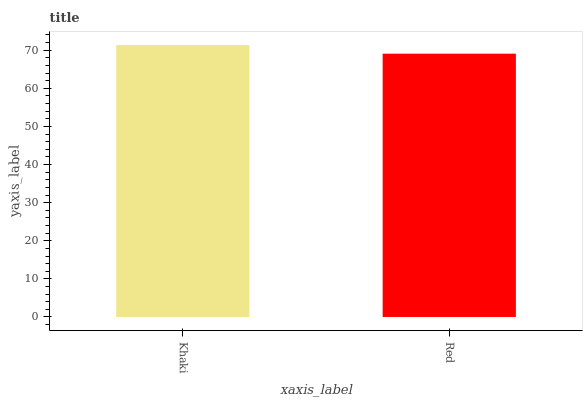Is Red the minimum?
Answer yes or no. Yes. Is Khaki the maximum?
Answer yes or no. Yes. Is Red the maximum?
Answer yes or no. No. Is Khaki greater than Red?
Answer yes or no. Yes. Is Red less than Khaki?
Answer yes or no. Yes. Is Red greater than Khaki?
Answer yes or no. No. Is Khaki less than Red?
Answer yes or no. No. Is Khaki the high median?
Answer yes or no. Yes. Is Red the low median?
Answer yes or no. Yes. Is Red the high median?
Answer yes or no. No. Is Khaki the low median?
Answer yes or no. No. 